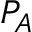Convert formula to latex. <formula><loc_0><loc_0><loc_500><loc_500>P _ { A }</formula> 